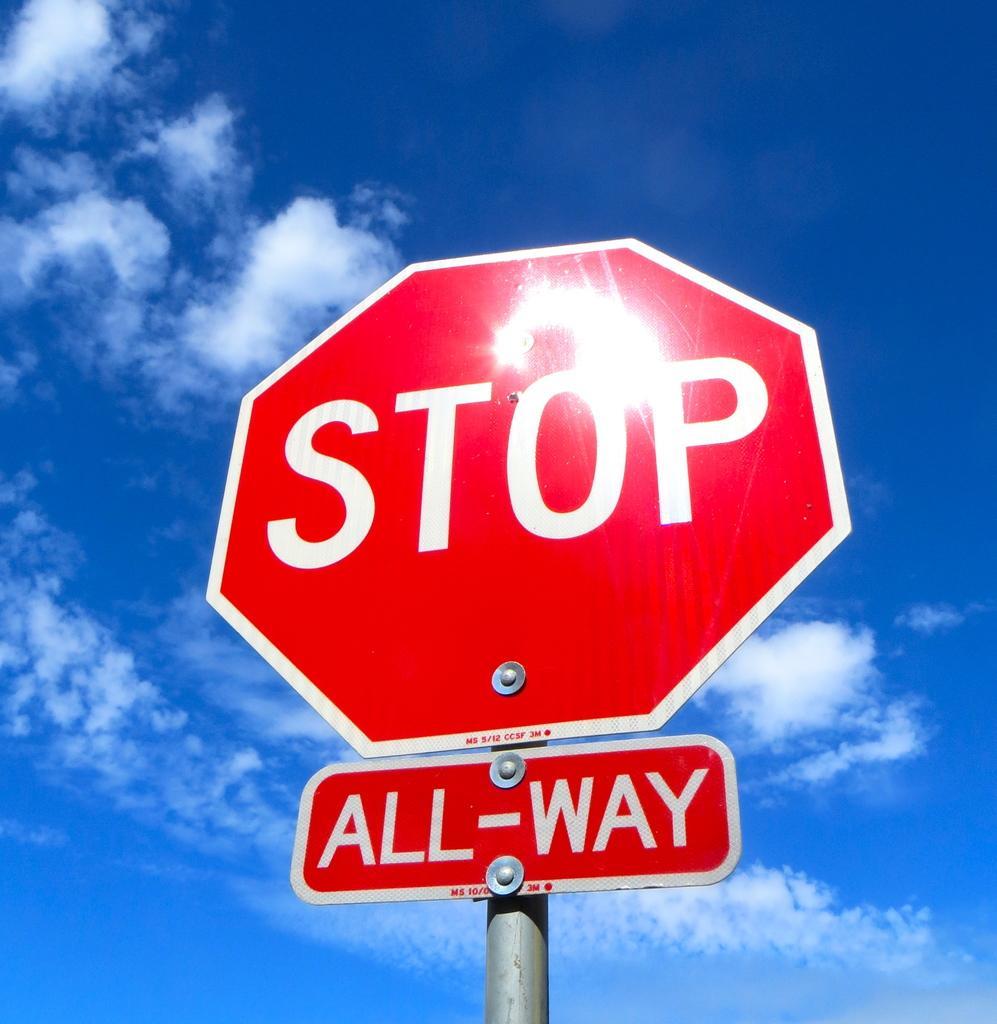Can you describe this image briefly? In this picture there are boards on the pole and there is text on the boards. At the top there is sky and there are clouds. 